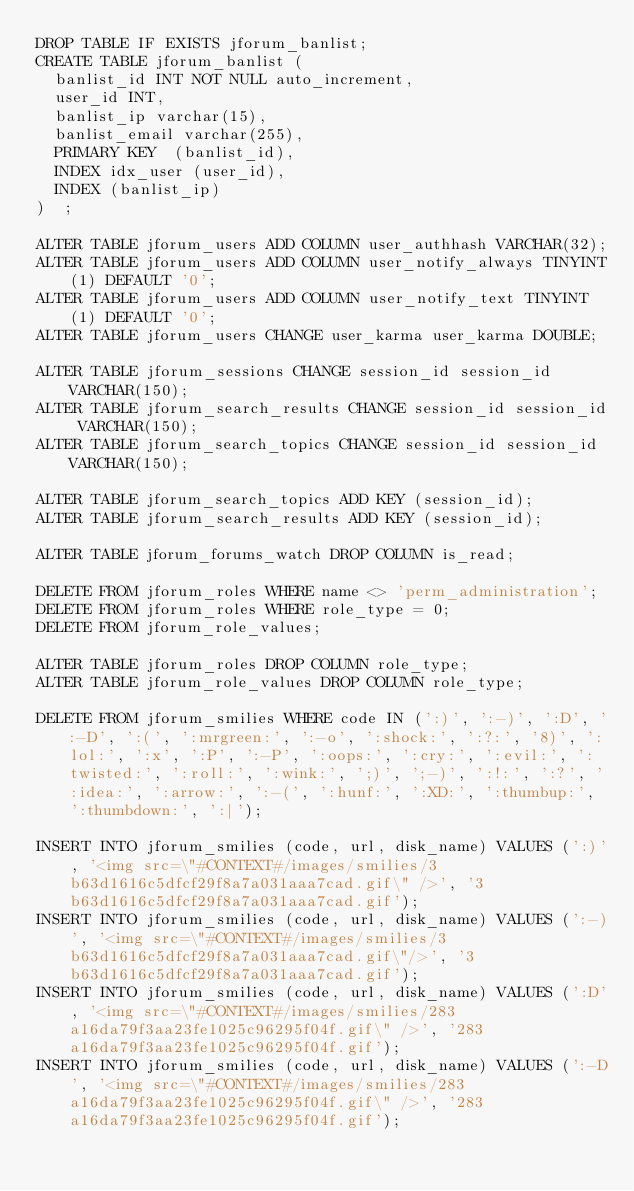Convert code to text. <code><loc_0><loc_0><loc_500><loc_500><_SQL_>DROP TABLE IF EXISTS jforum_banlist;
CREATE TABLE jforum_banlist (
  banlist_id INT NOT NULL auto_increment,
  user_id INT,
  banlist_ip varchar(15),
  banlist_email varchar(255),
  PRIMARY KEY  (banlist_id),
  INDEX idx_user (user_id),
  INDEX (banlist_ip)
)  ;

ALTER TABLE jforum_users ADD COLUMN user_authhash VARCHAR(32);
ALTER TABLE jforum_users ADD COLUMN user_notify_always TINYINT(1) DEFAULT '0';
ALTER TABLE jforum_users ADD COLUMN user_notify_text TINYINT(1) DEFAULT '0';
ALTER TABLE jforum_users CHANGE user_karma user_karma DOUBLE;

ALTER TABLE jforum_sessions CHANGE session_id session_id VARCHAR(150);
ALTER TABLE jforum_search_results CHANGE session_id session_id VARCHAR(150);
ALTER TABLE jforum_search_topics CHANGE session_id session_id VARCHAR(150);

ALTER TABLE jforum_search_topics ADD KEY (session_id);
ALTER TABLE jforum_search_results ADD KEY (session_id);

ALTER TABLE jforum_forums_watch DROP COLUMN is_read;

DELETE FROM jforum_roles WHERE name <> 'perm_administration';
DELETE FROM jforum_roles WHERE role_type = 0;
DELETE FROM jforum_role_values;

ALTER TABLE jforum_roles DROP COLUMN role_type;
ALTER TABLE jforum_role_values DROP COLUMN role_type;

DELETE FROM jforum_smilies WHERE code IN (':)', ':-)', ':D', ':-D', ':(', ':mrgreen:', ':-o', ':shock:', ':?:', '8)', ':lol:', ':x', ':P', ':-P', ':oops:', ':cry:', ':evil:', ':twisted:', ':roll:', ':wink:', ';)', ';-)', ':!:', ':?', ':idea:', ':arrow:', ':-(', ':hunf:', ':XD:', ':thumbup:', ':thumbdown:', ':|');

INSERT INTO jforum_smilies (code, url, disk_name) VALUES (':)', '<img src=\"#CONTEXT#/images/smilies/3b63d1616c5dfcf29f8a7a031aaa7cad.gif\" />', '3b63d1616c5dfcf29f8a7a031aaa7cad.gif');
INSERT INTO jforum_smilies (code, url, disk_name) VALUES (':-)', '<img src=\"#CONTEXT#/images/smilies/3b63d1616c5dfcf29f8a7a031aaa7cad.gif\"/>', '3b63d1616c5dfcf29f8a7a031aaa7cad.gif');
INSERT INTO jforum_smilies (code, url, disk_name) VALUES (':D', '<img src=\"#CONTEXT#/images/smilies/283a16da79f3aa23fe1025c96295f04f.gif\" />', '283a16da79f3aa23fe1025c96295f04f.gif');
INSERT INTO jforum_smilies (code, url, disk_name) VALUES (':-D', '<img src=\"#CONTEXT#/images/smilies/283a16da79f3aa23fe1025c96295f04f.gif\" />', '283a16da79f3aa23fe1025c96295f04f.gif');</code> 